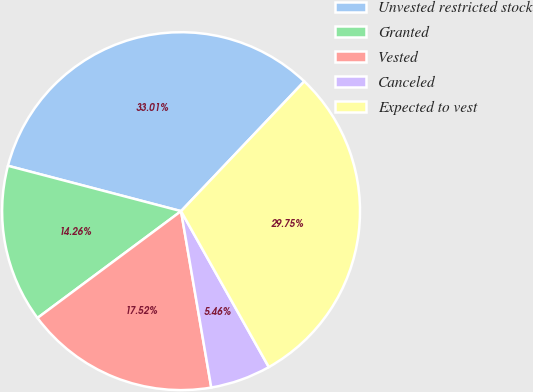<chart> <loc_0><loc_0><loc_500><loc_500><pie_chart><fcel>Unvested restricted stock<fcel>Granted<fcel>Vested<fcel>Canceled<fcel>Expected to vest<nl><fcel>33.01%<fcel>14.26%<fcel>17.52%<fcel>5.46%<fcel>29.75%<nl></chart> 